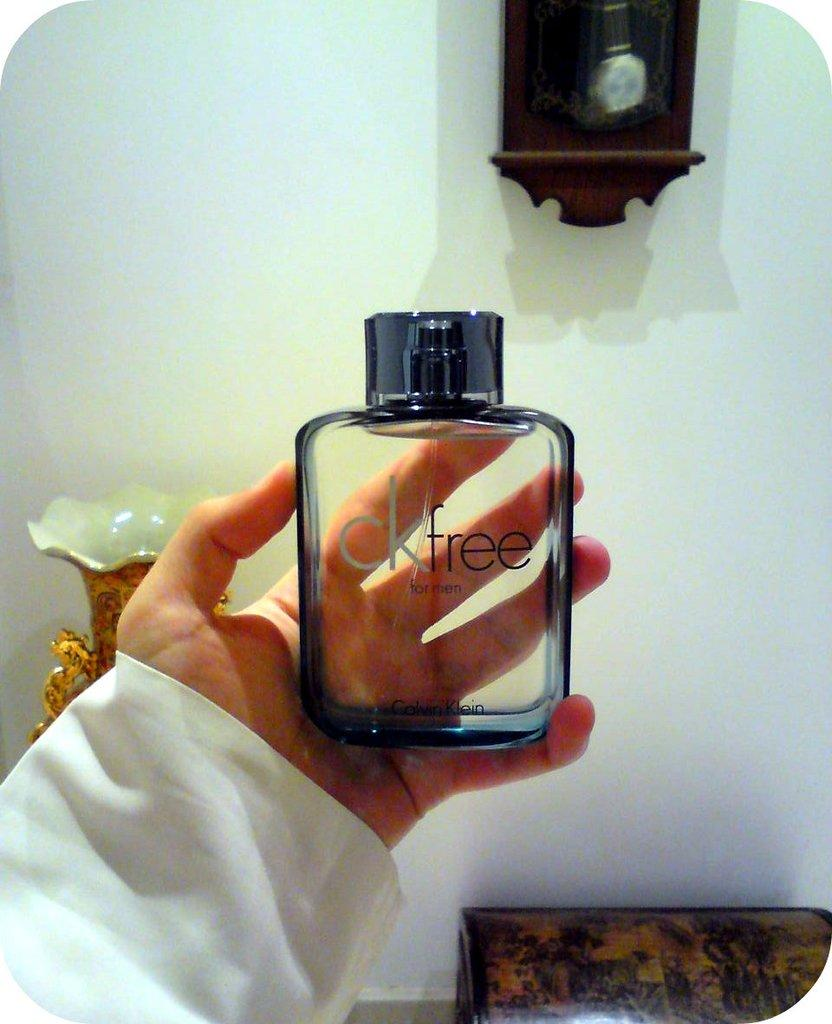<image>
Create a compact narrative representing the image presented. A hand holding a bottle CK Free for men cologne. 